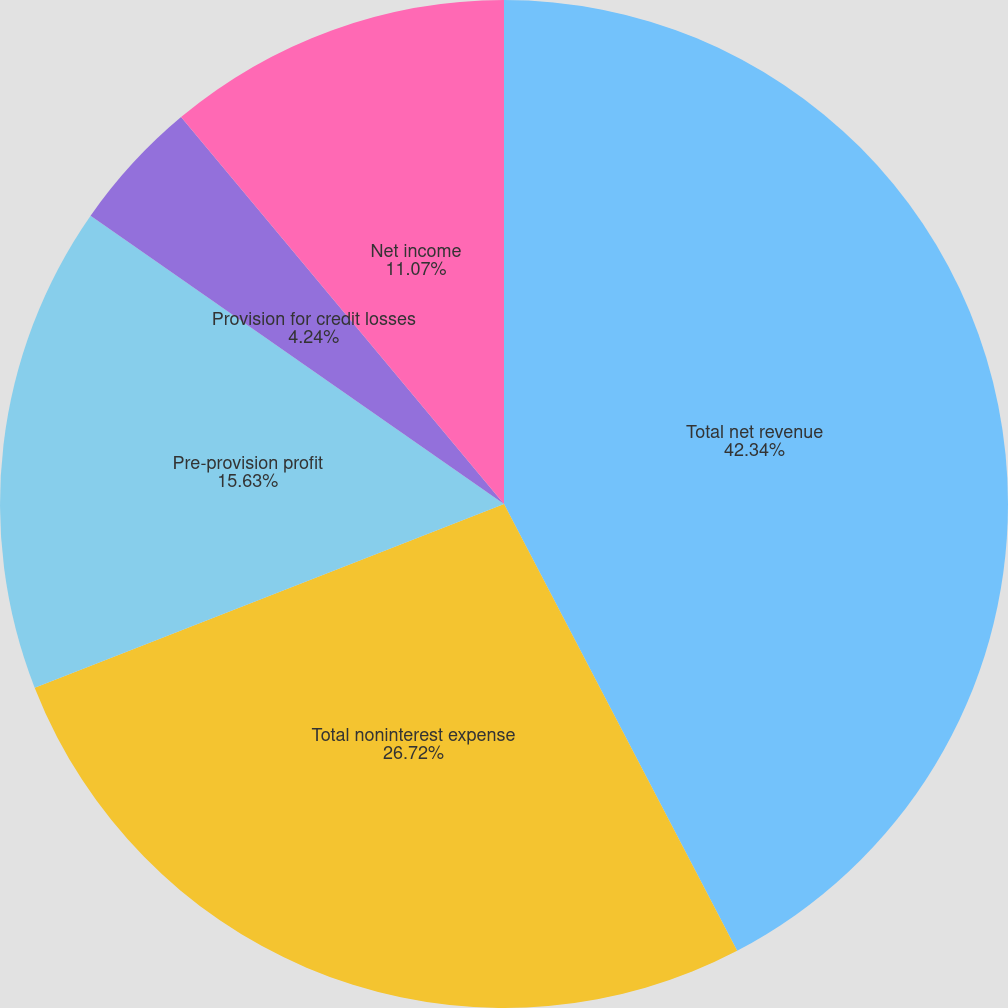Convert chart to OTSL. <chart><loc_0><loc_0><loc_500><loc_500><pie_chart><fcel>Total net revenue<fcel>Total noninterest expense<fcel>Pre-provision profit<fcel>Provision for credit losses<fcel>Net income<fcel>Diluted earnings per share<nl><fcel>42.35%<fcel>26.72%<fcel>15.63%<fcel>4.24%<fcel>11.07%<fcel>0.0%<nl></chart> 